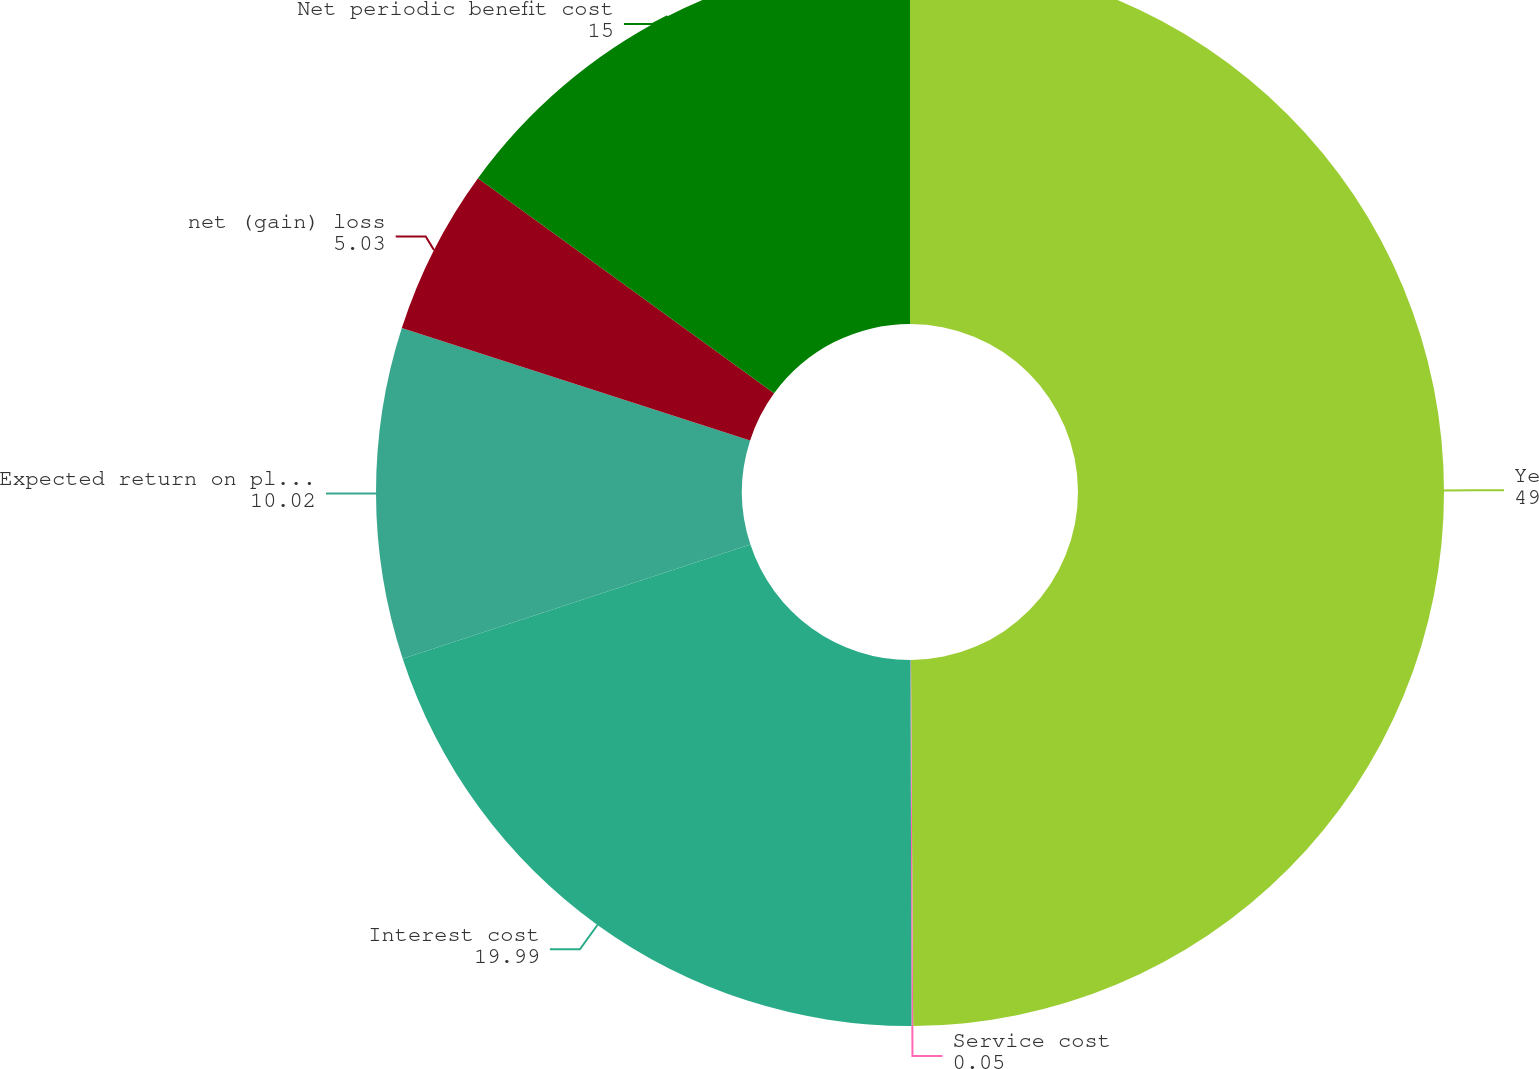Convert chart. <chart><loc_0><loc_0><loc_500><loc_500><pie_chart><fcel>Year Ended December 31<fcel>Service cost<fcel>Interest cost<fcel>Expected return on plan assets<fcel>net (gain) loss<fcel>Net periodic benefit cost<nl><fcel>49.9%<fcel>0.05%<fcel>19.99%<fcel>10.02%<fcel>5.03%<fcel>15.0%<nl></chart> 